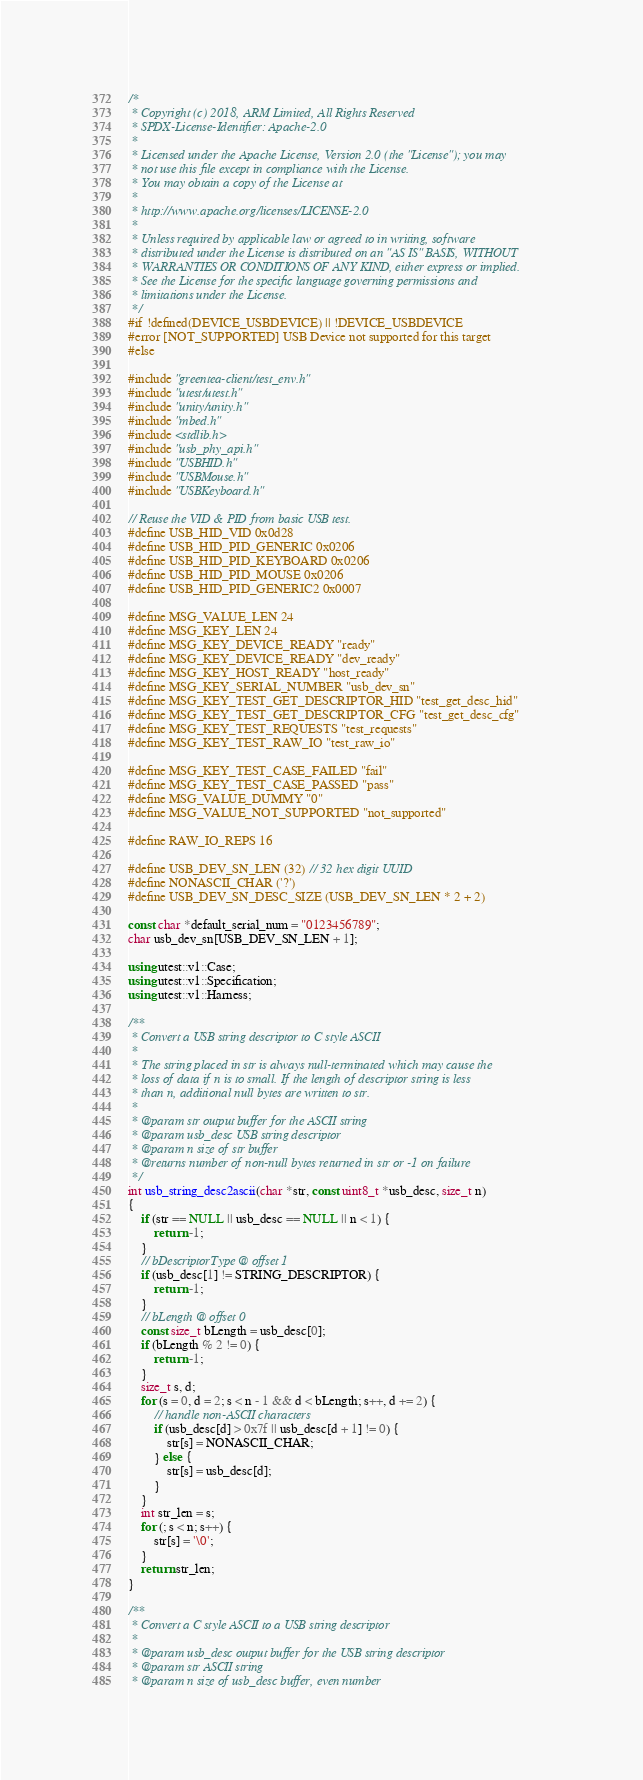Convert code to text. <code><loc_0><loc_0><loc_500><loc_500><_C++_>/*
 * Copyright (c) 2018, ARM Limited, All Rights Reserved
 * SPDX-License-Identifier: Apache-2.0
 *
 * Licensed under the Apache License, Version 2.0 (the "License"); you may
 * not use this file except in compliance with the License.
 * You may obtain a copy of the License at
 *
 * http://www.apache.org/licenses/LICENSE-2.0
 *
 * Unless required by applicable law or agreed to in writing, software
 * distributed under the License is distributed on an "AS IS" BASIS, WITHOUT
 * WARRANTIES OR CONDITIONS OF ANY KIND, either express or implied.
 * See the License for the specific language governing permissions and
 * limitations under the License.
 */
#if !defined(DEVICE_USBDEVICE) || !DEVICE_USBDEVICE
#error [NOT_SUPPORTED] USB Device not supported for this target
#else

#include "greentea-client/test_env.h"
#include "utest/utest.h"
#include "unity/unity.h"
#include "mbed.h"
#include <stdlib.h>
#include "usb_phy_api.h"
#include "USBHID.h"
#include "USBMouse.h"
#include "USBKeyboard.h"

// Reuse the VID & PID from basic USB test.
#define USB_HID_VID 0x0d28
#define USB_HID_PID_GENERIC 0x0206
#define USB_HID_PID_KEYBOARD 0x0206
#define USB_HID_PID_MOUSE 0x0206
#define USB_HID_PID_GENERIC2 0x0007

#define MSG_VALUE_LEN 24
#define MSG_KEY_LEN 24
#define MSG_KEY_DEVICE_READY "ready"
#define MSG_KEY_DEVICE_READY "dev_ready"
#define MSG_KEY_HOST_READY "host_ready"
#define MSG_KEY_SERIAL_NUMBER "usb_dev_sn"
#define MSG_KEY_TEST_GET_DESCRIPTOR_HID "test_get_desc_hid"
#define MSG_KEY_TEST_GET_DESCRIPTOR_CFG "test_get_desc_cfg"
#define MSG_KEY_TEST_REQUESTS "test_requests"
#define MSG_KEY_TEST_RAW_IO "test_raw_io"

#define MSG_KEY_TEST_CASE_FAILED "fail"
#define MSG_KEY_TEST_CASE_PASSED "pass"
#define MSG_VALUE_DUMMY "0"
#define MSG_VALUE_NOT_SUPPORTED "not_supported"

#define RAW_IO_REPS 16

#define USB_DEV_SN_LEN (32) // 32 hex digit UUID
#define NONASCII_CHAR ('?')
#define USB_DEV_SN_DESC_SIZE (USB_DEV_SN_LEN * 2 + 2)

const char *default_serial_num = "0123456789";
char usb_dev_sn[USB_DEV_SN_LEN + 1];

using utest::v1::Case;
using utest::v1::Specification;
using utest::v1::Harness;

/**
 * Convert a USB string descriptor to C style ASCII
 *
 * The string placed in str is always null-terminated which may cause the
 * loss of data if n is to small. If the length of descriptor string is less
 * than n, additional null bytes are written to str.
 *
 * @param str output buffer for the ASCII string
 * @param usb_desc USB string descriptor
 * @param n size of str buffer
 * @returns number of non-null bytes returned in str or -1 on failure
 */
int usb_string_desc2ascii(char *str, const uint8_t *usb_desc, size_t n)
{
    if (str == NULL || usb_desc == NULL || n < 1) {
        return -1;
    }
    // bDescriptorType @ offset 1
    if (usb_desc[1] != STRING_DESCRIPTOR) {
        return -1;
    }
    // bLength @ offset 0
    const size_t bLength = usb_desc[0];
    if (bLength % 2 != 0) {
        return -1;
    }
    size_t s, d;
    for (s = 0, d = 2; s < n - 1 && d < bLength; s++, d += 2) {
        // handle non-ASCII characters
        if (usb_desc[d] > 0x7f || usb_desc[d + 1] != 0) {
            str[s] = NONASCII_CHAR;
        } else {
            str[s] = usb_desc[d];
        }
    }
    int str_len = s;
    for (; s < n; s++) {
        str[s] = '\0';
    }
    return str_len;
}

/**
 * Convert a C style ASCII to a USB string descriptor
 *
 * @param usb_desc output buffer for the USB string descriptor
 * @param str ASCII string
 * @param n size of usb_desc buffer, even number</code> 